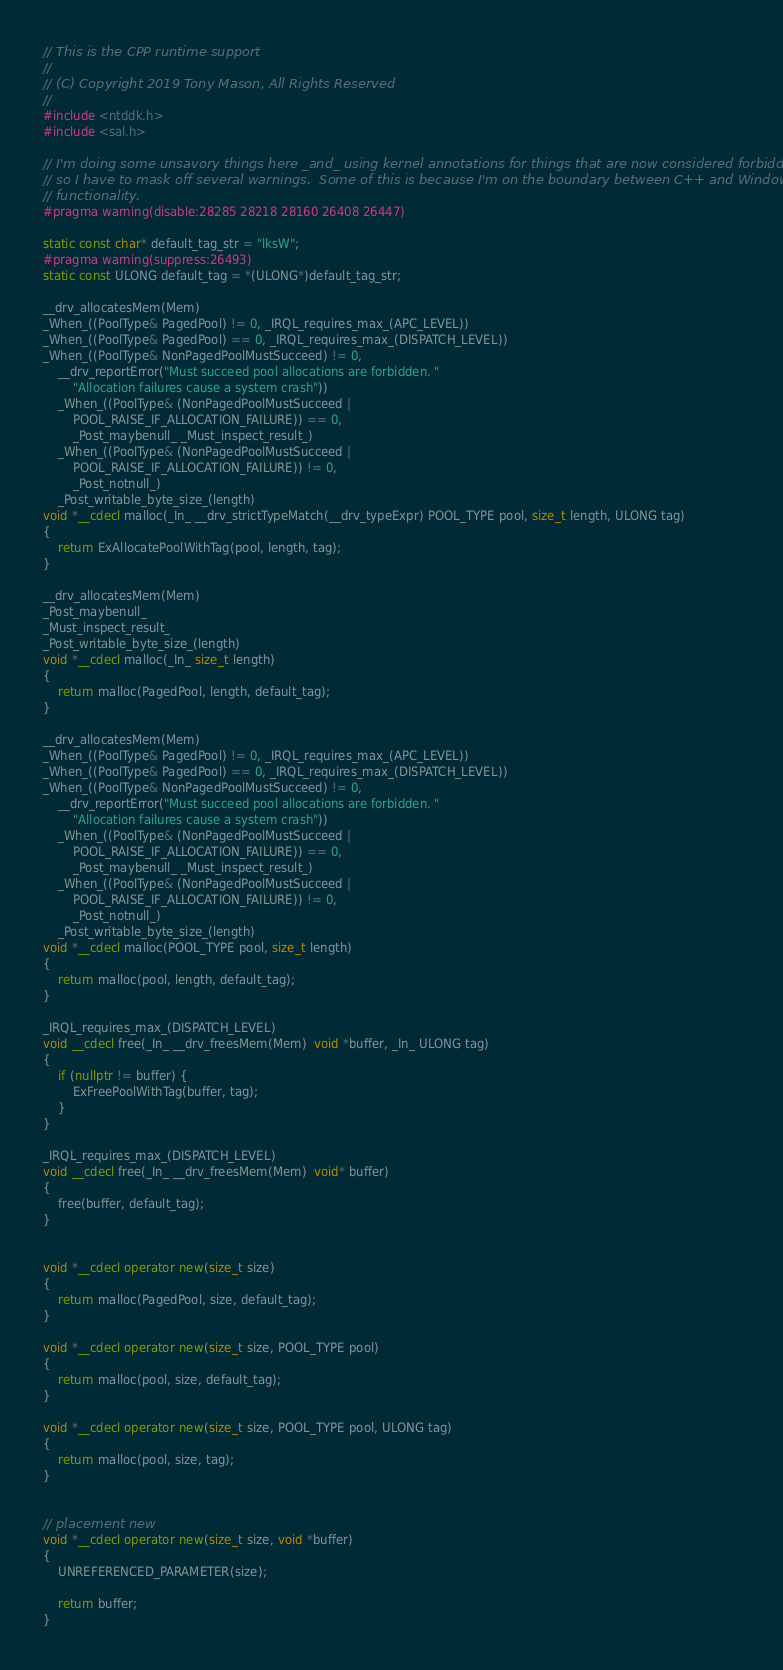<code> <loc_0><loc_0><loc_500><loc_500><_C++_>// This is the CPP runtime support
//
// (C) Copyright 2019 Tony Mason, All Rights Reserved
//
#include <ntddk.h>
#include <sal.h>

// I'm doing some unsavory things here _and_ using kernel annotations for things that are now considered forbidden
// so I have to mask off several warnings.  Some of this is because I'm on the boundary between C++ and Windows OS
// functionality.
#pragma warning(disable:28285 28218 28160 26408 26447)

static const char* default_tag_str = "lksW";
#pragma warning(suppress:26493)
static const ULONG default_tag = *(ULONG*)default_tag_str;

__drv_allocatesMem(Mem)
_When_((PoolType& PagedPool) != 0, _IRQL_requires_max_(APC_LEVEL))
_When_((PoolType& PagedPool) == 0, _IRQL_requires_max_(DISPATCH_LEVEL))
_When_((PoolType& NonPagedPoolMustSucceed) != 0,
	__drv_reportError("Must succeed pool allocations are forbidden. "
		"Allocation failures cause a system crash"))
	_When_((PoolType& (NonPagedPoolMustSucceed |
		POOL_RAISE_IF_ALLOCATION_FAILURE)) == 0,
		_Post_maybenull_ _Must_inspect_result_)
	_When_((PoolType& (NonPagedPoolMustSucceed |
		POOL_RAISE_IF_ALLOCATION_FAILURE)) != 0,
		_Post_notnull_)
	_Post_writable_byte_size_(length)
void *__cdecl malloc(_In_ __drv_strictTypeMatch(__drv_typeExpr) POOL_TYPE pool, size_t length, ULONG tag)
{
	return ExAllocatePoolWithTag(pool, length, tag);
}

__drv_allocatesMem(Mem)
_Post_maybenull_
_Must_inspect_result_
_Post_writable_byte_size_(length)
void *__cdecl malloc(_In_ size_t length)
{
	return malloc(PagedPool, length, default_tag);
}

__drv_allocatesMem(Mem)
_When_((PoolType& PagedPool) != 0, _IRQL_requires_max_(APC_LEVEL))
_When_((PoolType& PagedPool) == 0, _IRQL_requires_max_(DISPATCH_LEVEL))
_When_((PoolType& NonPagedPoolMustSucceed) != 0,
	__drv_reportError("Must succeed pool allocations are forbidden. "
		"Allocation failures cause a system crash"))
	_When_((PoolType& (NonPagedPoolMustSucceed |
		POOL_RAISE_IF_ALLOCATION_FAILURE)) == 0,
		_Post_maybenull_ _Must_inspect_result_)
	_When_((PoolType& (NonPagedPoolMustSucceed |
		POOL_RAISE_IF_ALLOCATION_FAILURE)) != 0,
		_Post_notnull_)
	_Post_writable_byte_size_(length)
void *__cdecl malloc(POOL_TYPE pool, size_t length)
{
	return malloc(pool, length, default_tag);
}

_IRQL_requires_max_(DISPATCH_LEVEL)
void __cdecl free(_In_ __drv_freesMem(Mem)  void *buffer, _In_ ULONG tag)
{
	if (nullptr != buffer) {
		ExFreePoolWithTag(buffer, tag);
	}
}

_IRQL_requires_max_(DISPATCH_LEVEL)
void __cdecl free(_In_ __drv_freesMem(Mem)  void* buffer)
{
	free(buffer, default_tag);
}


void *__cdecl operator new(size_t size)
{
	return malloc(PagedPool, size, default_tag);
}

void *__cdecl operator new(size_t size, POOL_TYPE pool)
{
	return malloc(pool, size, default_tag);
}

void *__cdecl operator new(size_t size, POOL_TYPE pool, ULONG tag)
{
	return malloc(pool, size, tag);
}


// placement new
void *__cdecl operator new(size_t size, void *buffer)
{
	UNREFERENCED_PARAMETER(size);

	return buffer;
}
</code> 